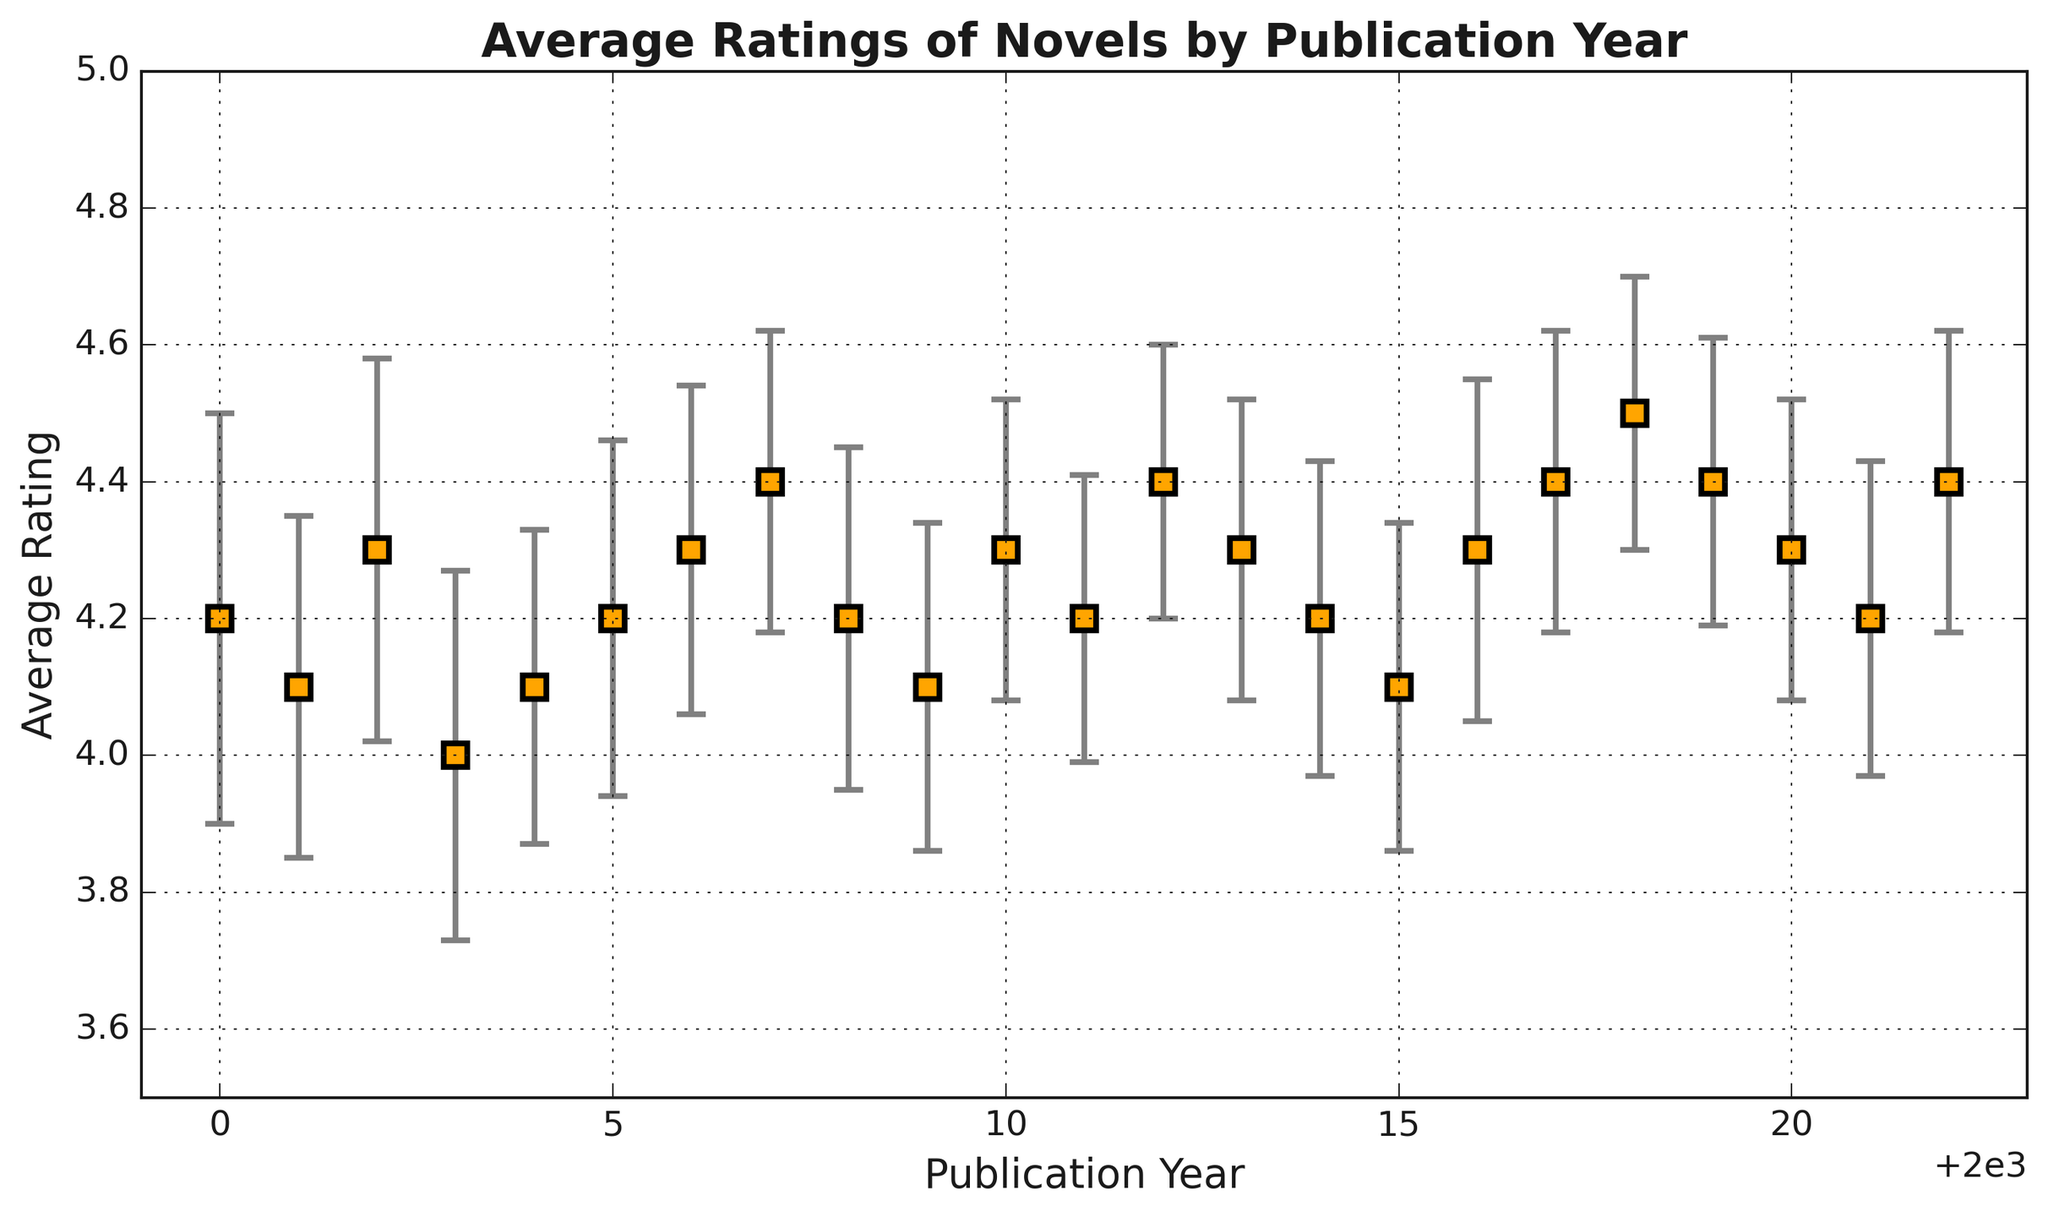What is the average rating of novels published in 2010? The figure shows the average rating of each year; for 2010, it is marked as 4.3.
Answer: 4.3 Which publication year has the highest average rating? By looking at the figure, the highest point on the y-axis corresponds to 2018 with an average rating of 4.5.
Answer: 2018 How many years have an average rating above 4.3? By inspecting the average ratings for each year: 2002, 2006, 2007, 2010, 2012, 2013, 2017, 2018, 2019, 2022 have ratings of 4.3 or higher. There are 10 such years.
Answer: 10 years Compare the average ratings of novels published in 2018 and 2019. Which year has a higher average rating and by how much? The average rating in 2018 is 4.5 and in 2019 it is 4.4. 2018 has a higher rating by 0.1.
Answer: 2018 by 0.1 What trends do you notice in the average ratings between 2000 and 2022? The figure shows that average ratings fluctuate around the 4.2–4.4 range, with a peak in 2018 and small dips below 4.2 in some years. Overall, the ratings are relatively stable with minor variations.
Answer: Stable with minor fluctuations Identify the year with the largest error estimate and state that estimate. Observing the error bars, 2000 has the largest error estimate represented by a longer error bar of 0.3.
Answer: 2000, 0.3 Is there a significant difference between the average ratings of novels published in 2007 and 2017? The average rating in 2007 is 4.4 and in 2017 also 4.4. There is no significant difference as they have the same average rating.
Answer: No What is the visual trend of the error estimates over the years? The error estimates generally decrease over the years, starting higher around 2000 and becoming smaller towards 2022.
Answer: Decreasing Which year has the lowest average rating and what is it? According to the figure, the lowest average rating occurs in 2003 with a value of 4.0.
Answer: 2003, 4.0 How do the average ratings of novels in 2005 and 2022 compare, and what might this suggest in the context of literature quality over time? 2005 has an average rating of 4.2, while 2022 has an average rating of 4.4. This might suggest a slight improvement in the perceived quality of literature over time, as reflected by online ratings.
Answer: 2022 is higher, suggesting improvement 